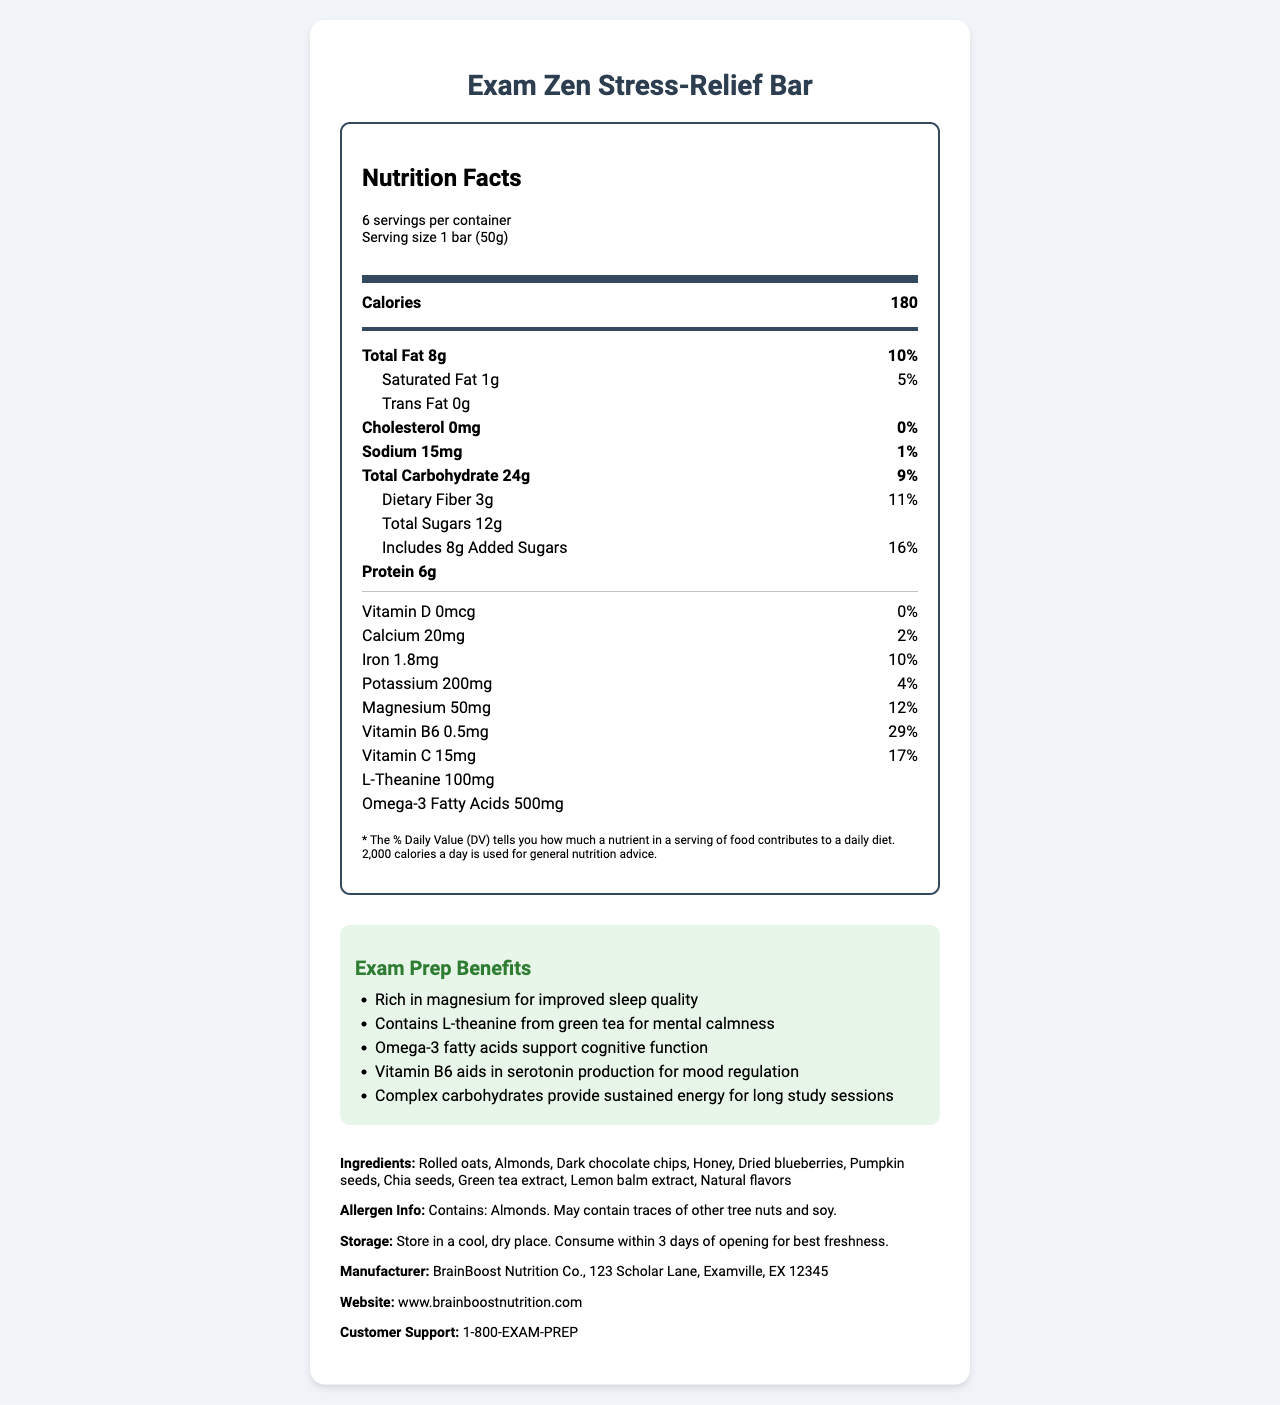What is the calorie count per serving? The document specifies that one serving of the "Exam Zen Stress-Relief Bar" contains 180 calories.
Answer: 180 How much dietary fiber does the bar contain per serving? The nutrition label lists 3 grams of dietary fiber per serving.
Answer: 3g How many servings are there per container? The document clearly states that there are 6 servings per container.
Answer: 6 Which nutrient has the highest daily value percentage in this product? The nutrition label shows that Vitamin B6 has a daily value of 29%, which is the highest listed.
Answer: Vitamin B6 What are the main ingredients in the Exam Zen Stress-Relief Bar? The document includes a section listing all the ingredients in the product.
Answer: Rolled oats, Almonds, Dark chocolate chips, Honey, Dried blueberries, Pumpkin seeds, Chia seeds, Green tea extract, Lemon balm extract, Natural flavors Which attribute shows the level of Sodium in this product? A. 20mg B. 15mg C. 50mg D. 200mg The nutrition label indicates that the sodium level is 15mg per serving.
Answer: B Which of the following benefits is NOT listed for exam prep? I. Improved sleep quality II. Supporting cognitive function III. Weight loss IV. Mental calmness The document lists benefits such as improved sleep quality, supporting cognitive function, and mental calmness but does not mention weight loss.
Answer: III Does the bar contain any added sugars? The nutrition label specifies that the bar includes 8 grams of added sugars.
Answer: Yes Mention three benefits of consuming this bar for exam preparation. The document specifies these benefits in the "Exam Prep Benefits" section.
Answer: Improved sleep quality, Mental calmness, Cognitive function support Summarize the main idea of the document. This summary captures the document's comprehensive details about the product, such as its nutrition facts, benefits for exam prep, and practical information about storage and manufacturer.
Answer: The document provides detailed nutrition facts for the "Exam Zen Stress-Relief Bar," highlighting its ingredients, nutritional content, exam preparation benefits, storage instructions, and manufacturer information. How much Vitamin D is in the bar per serving? The nutrition label shows that there is 0 micrograms of Vitamin D per serving.
Answer: 0mcg Identify the protein content per serving. The document states that each serving contains 6 grams of protein.
Answer: 6g What is the address of the manufacturer? The document lists the manufacturer's address as 123 Scholar Lane, Examville, EX 12345.
Answer: 123 Scholar Lane, Examville, EX 12345 Can you determine if the bar is gluten-free? The document does not provide information about whether the product is gluten-free.
Answer: Not enough information What is the storage instruction for this product? The document specifies these storage instructions to maintain the product's freshness.
Answer: Store in a cool, dry place. Consume within 3 days of opening for best freshness. 